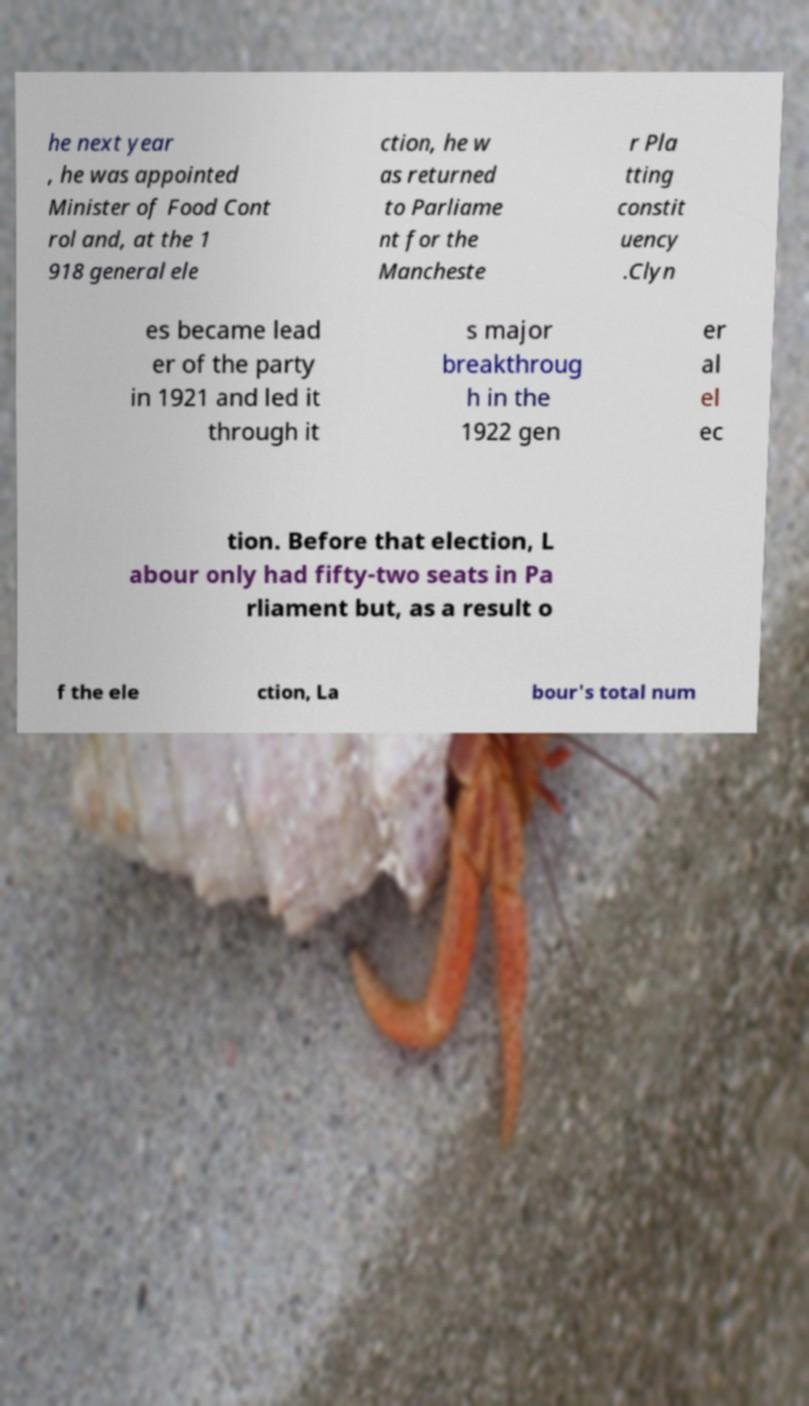Can you accurately transcribe the text from the provided image for me? he next year , he was appointed Minister of Food Cont rol and, at the 1 918 general ele ction, he w as returned to Parliame nt for the Mancheste r Pla tting constit uency .Clyn es became lead er of the party in 1921 and led it through it s major breakthroug h in the 1922 gen er al el ec tion. Before that election, L abour only had fifty-two seats in Pa rliament but, as a result o f the ele ction, La bour's total num 